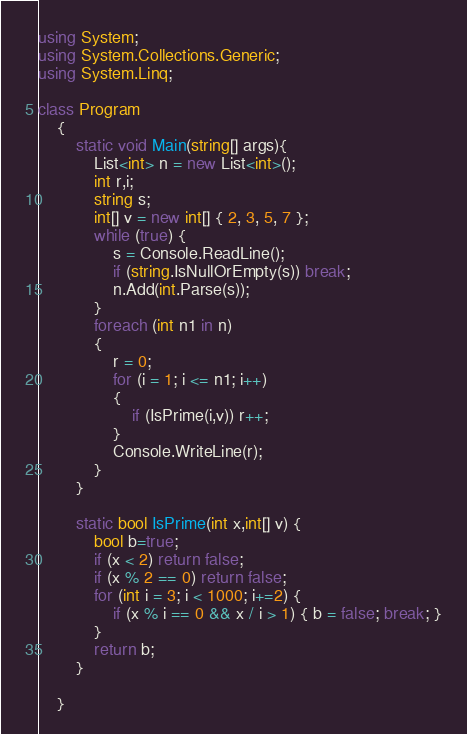Convert code to text. <code><loc_0><loc_0><loc_500><loc_500><_C#_>using System;
using System.Collections.Generic;
using System.Linq;

class Program
    {
        static void Main(string[] args){
            List<int> n = new List<int>();
            int r,i;
            string s;
            int[] v = new int[] { 2, 3, 5, 7 };
            while (true) {
                s = Console.ReadLine();
                if (string.IsNullOrEmpty(s)) break;
                n.Add(int.Parse(s));
            }
            foreach (int n1 in n)
            {
                r = 0;
                for (i = 1; i <= n1; i++)
                {
                    if (IsPrime(i,v)) r++;
                }
                Console.WriteLine(r);
            }
        }

        static bool IsPrime(int x,int[] v) {
            bool b=true;
            if (x < 2) return false;
            if (x % 2 == 0) return false;
            for (int i = 3; i < 1000; i+=2) {
                if (x % i == 0 && x / i > 1) { b = false; break; }
            }
            return b;
        }

    }</code> 